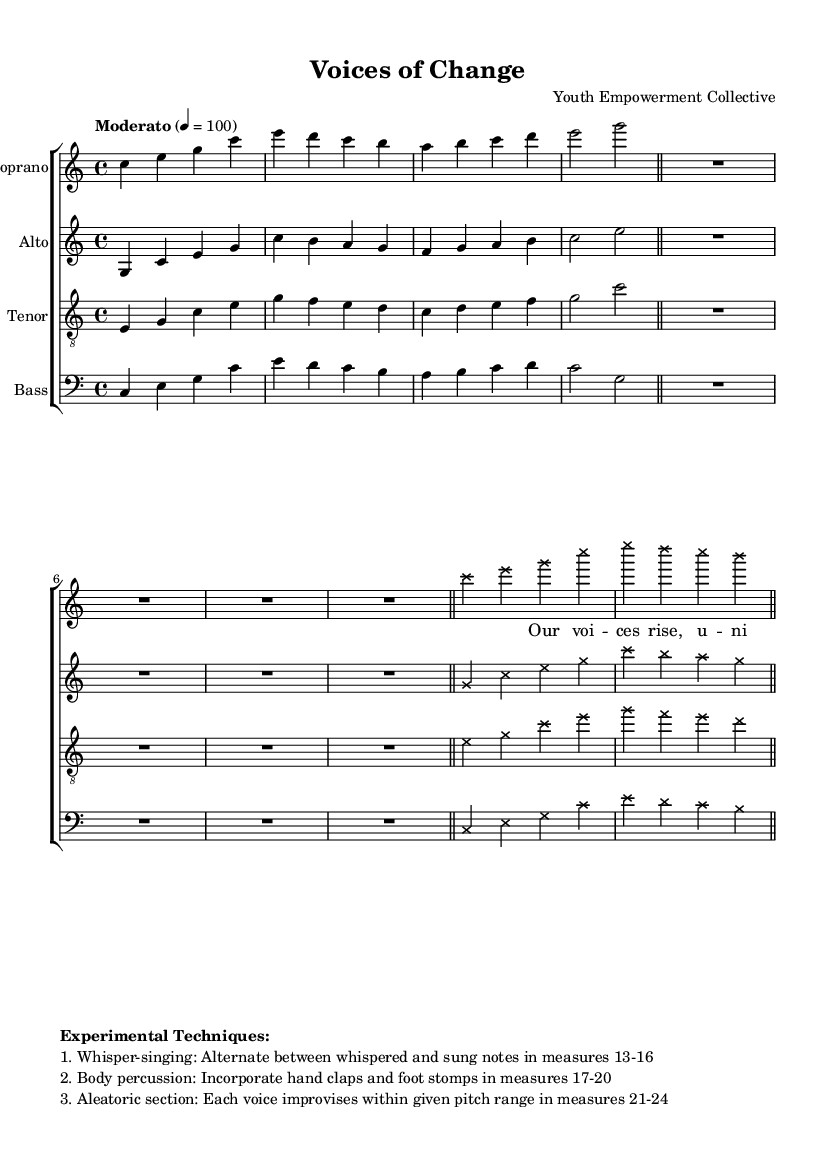What is the key signature of this music? The key signature is indicated at the beginning of the staff and it shows no sharps or flats, which corresponds to C major.
Answer: C major What is the time signature of the piece? The time signature is found at the beginning of the score, represented as 4/4, which indicates there are four beats per measure with a quarter note receiving one beat.
Answer: 4/4 What is the tempo marking? The tempo marking is specified as "Moderato" followed by a metronome indication of 4 = 100, which suggests a moderate speed of 100 beats per minute.
Answer: Moderato Which voices are included in this arrangement? The arrangement includes Soprano, Alto, Tenor, and Bass, all of which are clearly labeled in the score with respective staves.
Answer: Soprano, Alto, Tenor, Bass How many measures are there in the vocal parts before the first rest? By counting the measures from the beginning of the vocal sections up to the first rest, I find there are 16 measures that appear before the first rest symbol in the parts.
Answer: 16 What is one of the experimental techniques specified in the score? The score outlines several experimental techniques, one being "Whisper-singing," which instructs the singers to alternate between whispered and sung notes in specific measures.
Answer: Whisper-singing What is the purpose of the aleatoric section? The aleatoric section, indicated in measures 21-24, allows each voice to improvise within a given pitch range, creating a spontaneous and自由 atmosphere that reflects the themes of youth empowerment and social change.
Answer: Improvisation 